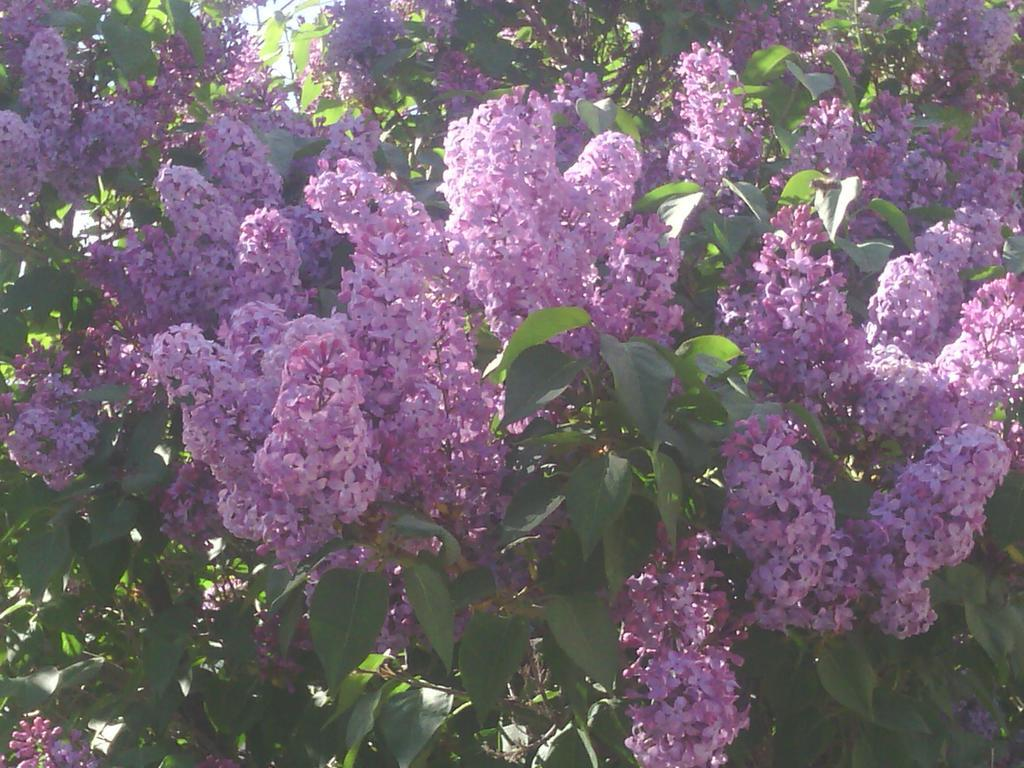What type of living organisms can be seen in the image? Plants can be seen in the image. What specific features do the plants have? The plants have flowers. What color are the flowers? The flowers are in purple color. Can you tell me how many monkeys are sitting on the flowers in the image? There are no monkeys present in the image; it features plants with purple flowers. What scene is depicted in the image? The image does not depict a scene; it simply shows plants with purple flowers. 